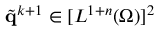Convert formula to latex. <formula><loc_0><loc_0><loc_500><loc_500>\tilde { q } ^ { k + 1 } \in [ L ^ { 1 + n } ( \Omega ) ] ^ { 2 }</formula> 